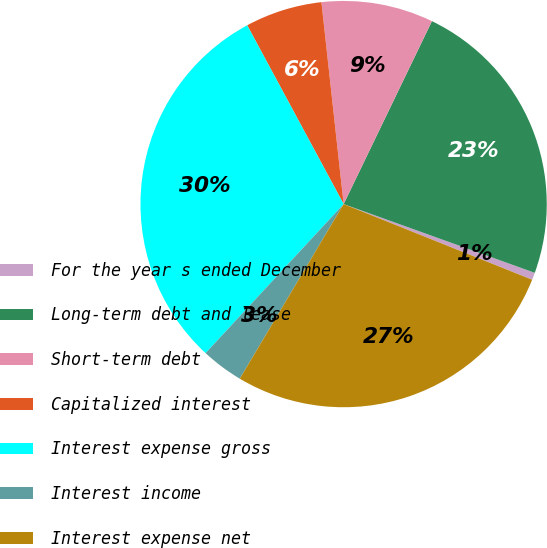Convert chart. <chart><loc_0><loc_0><loc_500><loc_500><pie_chart><fcel>For the year s ended December<fcel>Long-term debt and lease<fcel>Short-term debt<fcel>Capitalized interest<fcel>Interest expense gross<fcel>Interest income<fcel>Interest expense net<nl><fcel>0.58%<fcel>23.34%<fcel>8.9%<fcel>6.13%<fcel>30.24%<fcel>3.35%<fcel>27.47%<nl></chart> 